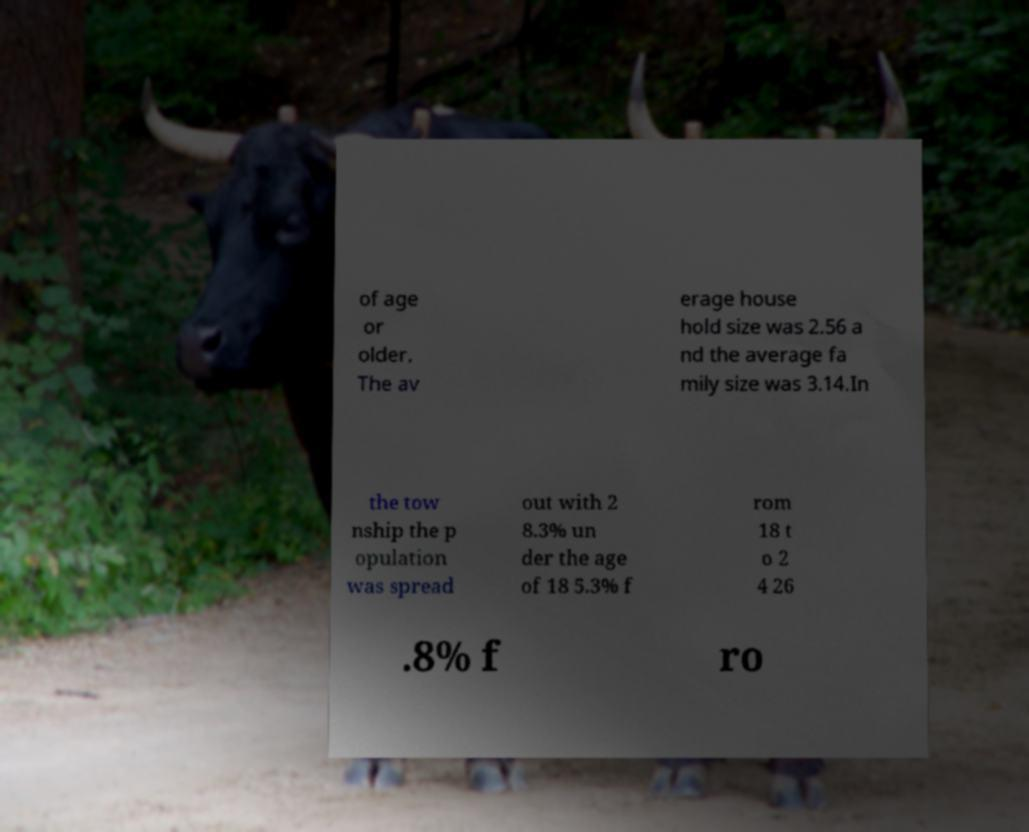Can you accurately transcribe the text from the provided image for me? of age or older. The av erage house hold size was 2.56 a nd the average fa mily size was 3.14.In the tow nship the p opulation was spread out with 2 8.3% un der the age of 18 5.3% f rom 18 t o 2 4 26 .8% f ro 